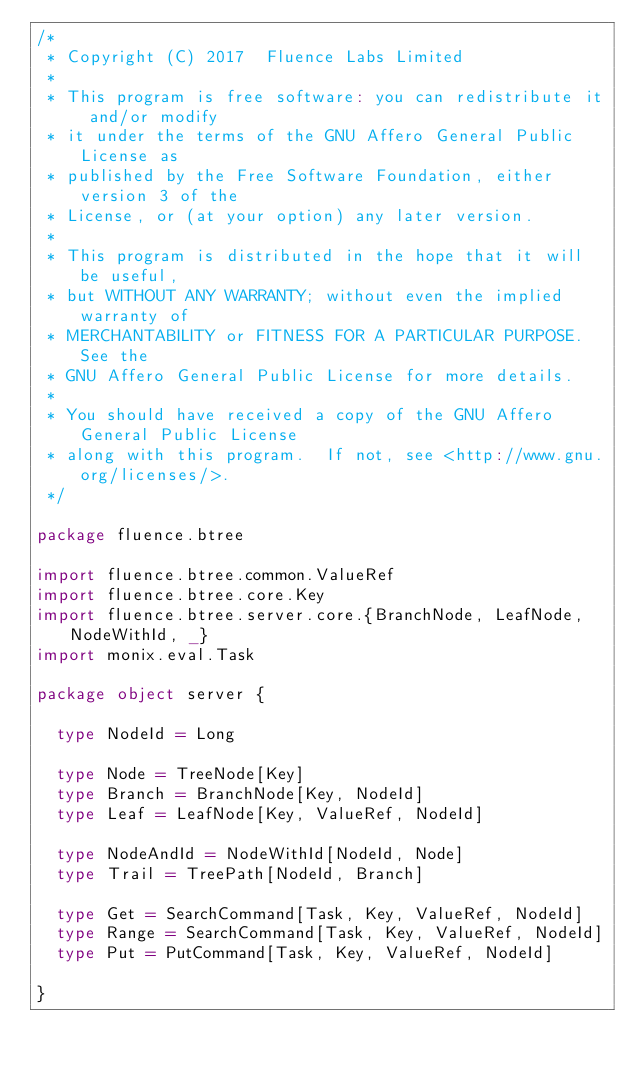Convert code to text. <code><loc_0><loc_0><loc_500><loc_500><_Scala_>/*
 * Copyright (C) 2017  Fluence Labs Limited
 *
 * This program is free software: you can redistribute it and/or modify
 * it under the terms of the GNU Affero General Public License as
 * published by the Free Software Foundation, either version 3 of the
 * License, or (at your option) any later version.
 *
 * This program is distributed in the hope that it will be useful,
 * but WITHOUT ANY WARRANTY; without even the implied warranty of
 * MERCHANTABILITY or FITNESS FOR A PARTICULAR PURPOSE.  See the
 * GNU Affero General Public License for more details.
 *
 * You should have received a copy of the GNU Affero General Public License
 * along with this program.  If not, see <http://www.gnu.org/licenses/>.
 */

package fluence.btree

import fluence.btree.common.ValueRef
import fluence.btree.core.Key
import fluence.btree.server.core.{BranchNode, LeafNode, NodeWithId, _}
import monix.eval.Task

package object server {

  type NodeId = Long

  type Node = TreeNode[Key]
  type Branch = BranchNode[Key, NodeId]
  type Leaf = LeafNode[Key, ValueRef, NodeId]

  type NodeAndId = NodeWithId[NodeId, Node]
  type Trail = TreePath[NodeId, Branch]

  type Get = SearchCommand[Task, Key, ValueRef, NodeId]
  type Range = SearchCommand[Task, Key, ValueRef, NodeId]
  type Put = PutCommand[Task, Key, ValueRef, NodeId]

}
</code> 